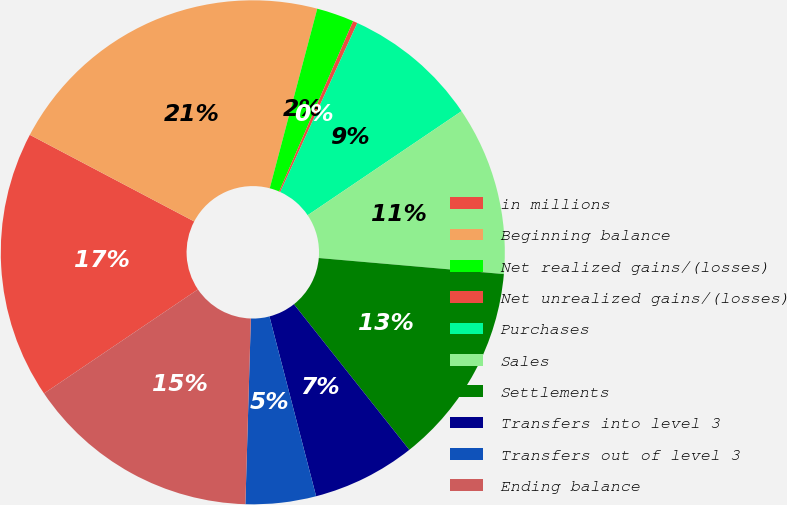Convert chart. <chart><loc_0><loc_0><loc_500><loc_500><pie_chart><fcel>in millions<fcel>Beginning balance<fcel>Net realized gains/(losses)<fcel>Net unrealized gains/(losses)<fcel>Purchases<fcel>Sales<fcel>Settlements<fcel>Transfers into level 3<fcel>Transfers out of level 3<fcel>Ending balance<nl><fcel>17.18%<fcel>21.4%<fcel>2.4%<fcel>0.29%<fcel>8.73%<fcel>10.84%<fcel>12.96%<fcel>6.62%<fcel>4.51%<fcel>15.07%<nl></chart> 